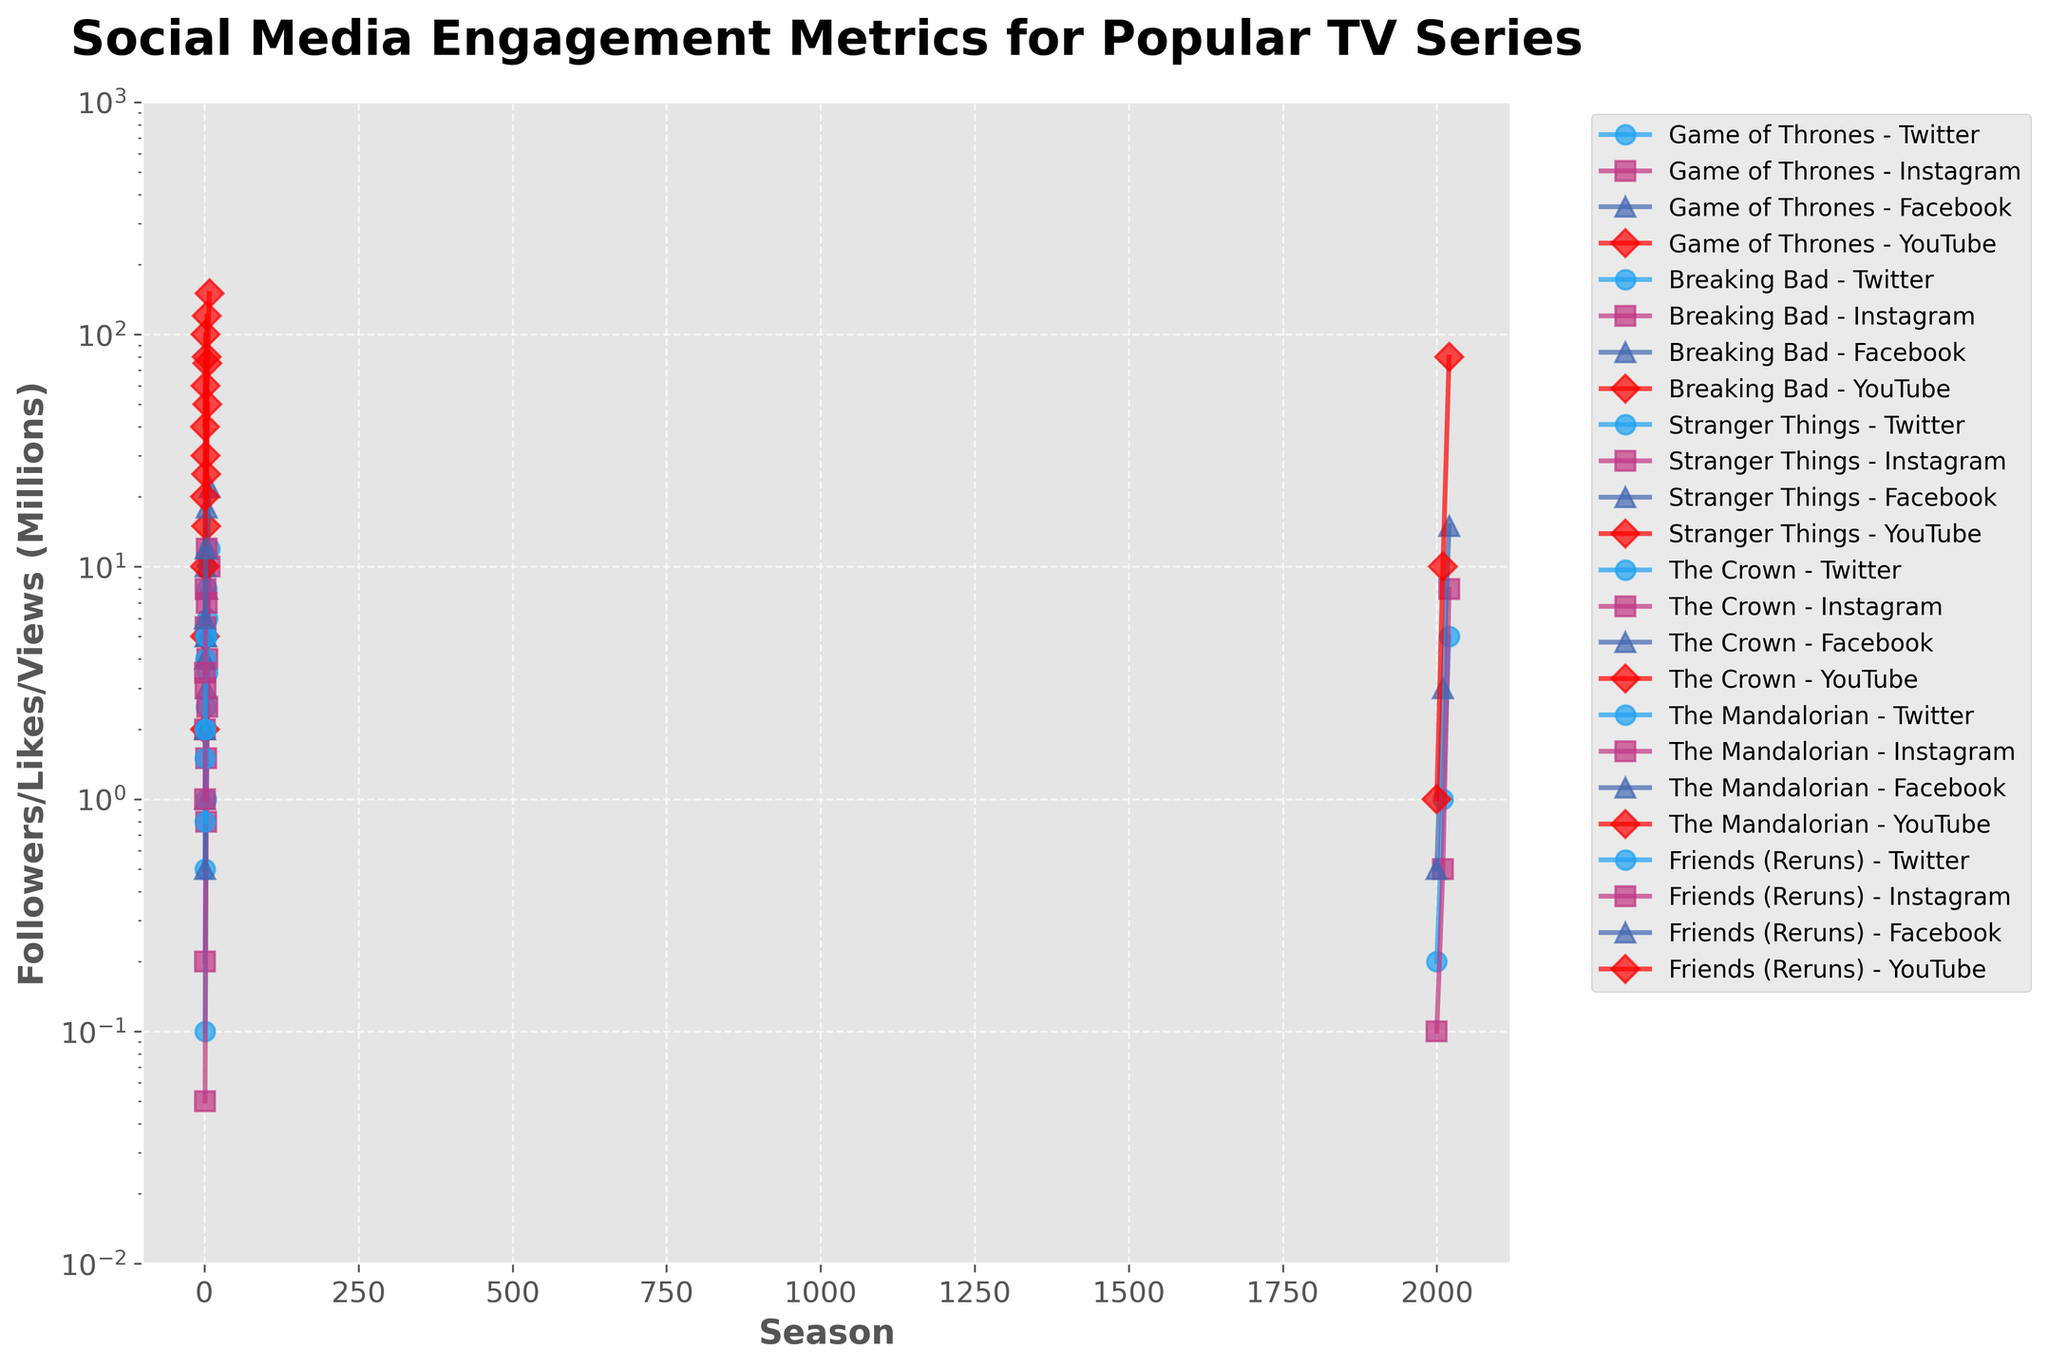Which series gained the most Instagram followers between its first and final season? To find out which series gained the most Instagram followers between its first and final season, look at the Instagram followers at the first and last seasons for each series and then calculate the difference. Game of Thrones increased by 9.8M (10 - 0.2), Breaking Bad by 2.45M (2.5 - 0.05), Stranger Things by 10M (12 - 2), The Crown by 6M (7 - 1), The Mandalorian by 4.5M (8 - 3.5), and Friends increased by 7.5M (8 - 0.5). The series with the highest gain is Stranger Things with 10M followers.
Answer: Stranger Things Which series had the highest Facebook Likes in its final season? To determine the series with the highest Facebook Likes in its final season, examine the final data points for each series on the Facebook Likes metric. Game of Thrones had 22M, Breaking Bad had 8M, Stranger Things had 18M, The Crown had 11M, The Mandalorian had 12M, and Friends (Reruns) had 15M. Game of Thrones had the highest number of Facebook Likes in its final season.
Answer: Game of Thrones How many millions of YouTube views did Stranger Things gain between seasons 1 and 4? Look at the YouTube views for Stranger Things in season 1 (20M) and season 4 (120M). Calculate the difference: 120M - 20M equals 100M.
Answer: 100M By what factor did Game of Thrones’ YouTube views increase from season 1 to season 8? Find the YouTube views for Game of Thrones in season 1 (5M) and season 8 (150M). Divide the final views by the initial views: 150M / 5M equals 30. The YouTube views increased by a factor of 30.
Answer: 30 Which series had the slowest growth on Twitter from the first to the last recorded season? Calculate the difference in Twitter followers from the first to the last recorded season for each series: Game of Thrones (12M - 0.5M = 11.5M), Breaking Bad (3.5M - 0.1M = 3.4M), Stranger Things (8M - 1.5M = 6.5M), The Crown (5M - 0.8M = 4.2M), The Mandalorian (5M - 2M = 3M), and Friends (5M - 0.2M = 4.8M). Breaking Bad had the slowest growth at 3.4M.
Answer: Breaking Bad Which series had an equal number of Facebook Likes and YouTube Views in any recorded season? Compare the number of Facebook Likes and YouTube Views across all recorded seasons for each series. Breaking Bad in season 5 had 8M Facebook Likes and 8M YouTube Views.
Answer: Breaking Bad In which season did Stranger Things surpass 5 million Twitter Followers? Check the Twitter Followers data for Stranger Things over the seasons. Stranger Things had 4M followers in season 2 and 8M in season 4. Therefore, it surpassed 5M by season 4.
Answer: Season 4 Which platform showed the highest overall engagement for Friends (Reruns) over the recorded years? Compare the final recorded values for each platform for Friends (Reruns): Twitter (5M), Instagram (8M), Facebook (15M), YouTube (80M). The highest overall engagement was on YouTube with 80M views.
Answer: YouTube 